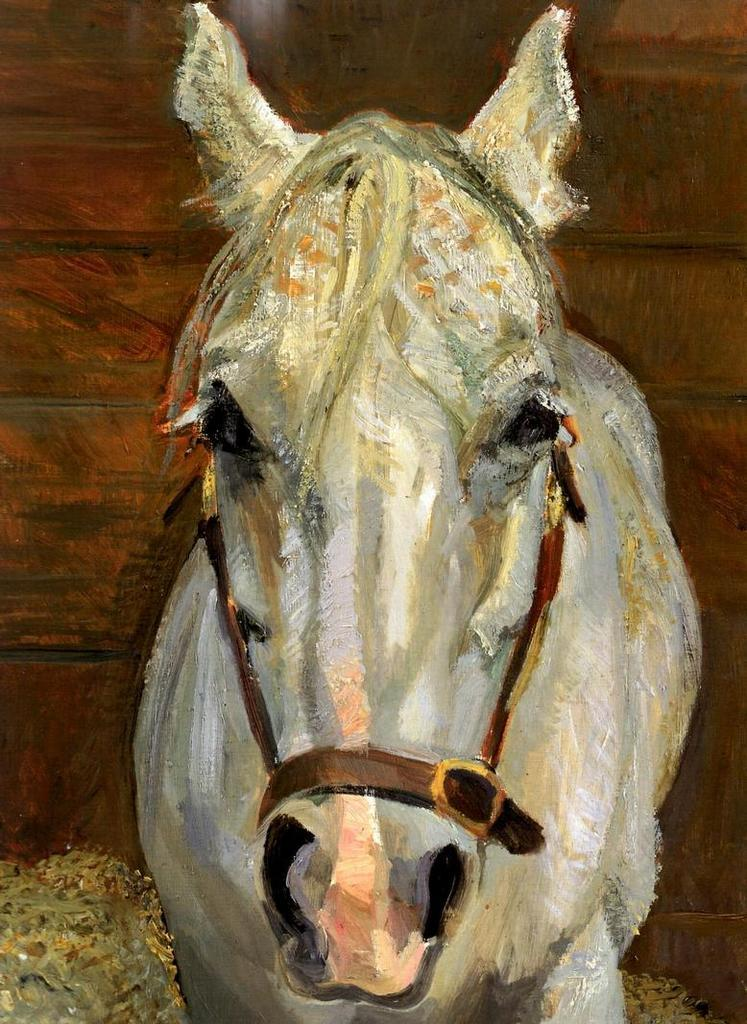What is the main subject of the painting in the image? The main subject of the painting in the image is a horse. What color is the horse in the painting? The horse is white in color. How is the horse depicted in the painting? The horse is depicted from the front. What is holding the horse in place in the painting? The horse is tied with belts. What can be seen in the background of the painting? There is a wooden wall in the background of the image. How many snails are crawling on the horse's back in the image? There are no snails present in the image; the horse is depicted without any snails on its back. 